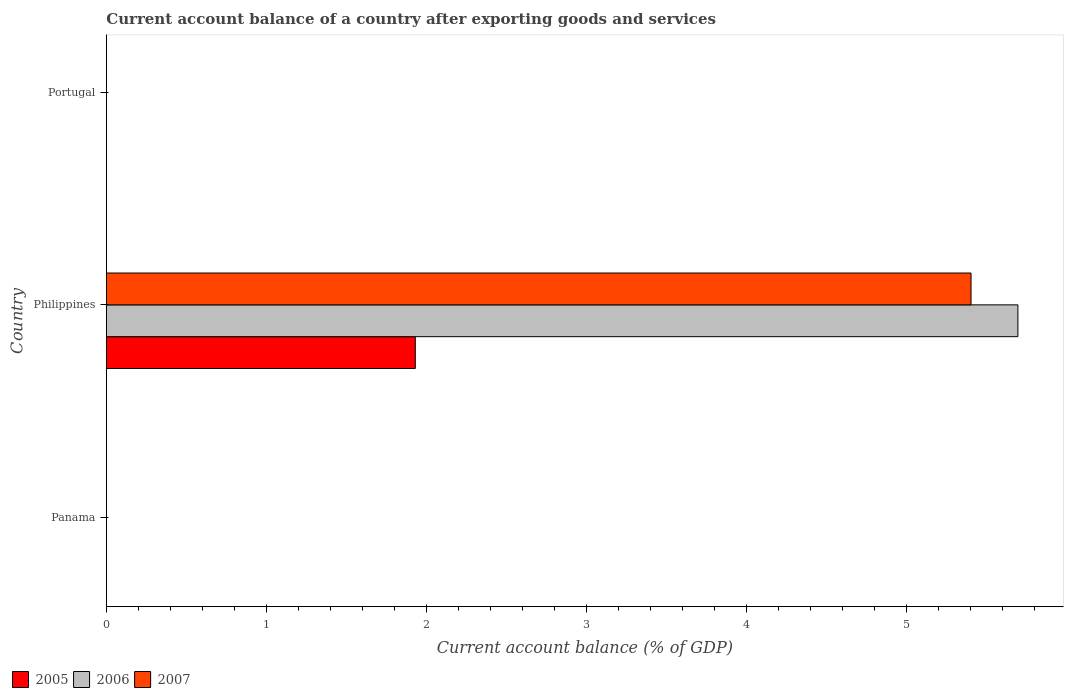Are the number of bars per tick equal to the number of legend labels?
Keep it short and to the point. No. How many bars are there on the 1st tick from the top?
Keep it short and to the point. 0. In how many cases, is the number of bars for a given country not equal to the number of legend labels?
Your answer should be very brief. 2. What is the account balance in 2007 in Portugal?
Provide a succinct answer. 0. Across all countries, what is the maximum account balance in 2005?
Offer a very short reply. 1.93. Across all countries, what is the minimum account balance in 2007?
Keep it short and to the point. 0. In which country was the account balance in 2007 maximum?
Provide a short and direct response. Philippines. What is the total account balance in 2005 in the graph?
Offer a very short reply. 1.93. What is the difference between the account balance in 2006 in Panama and the account balance in 2007 in Portugal?
Provide a short and direct response. 0. What is the average account balance in 2006 per country?
Keep it short and to the point. 1.9. What is the difference between the account balance in 2005 and account balance in 2007 in Philippines?
Make the answer very short. -3.47. In how many countries, is the account balance in 2005 greater than 4.6 %?
Keep it short and to the point. 0. What is the difference between the highest and the lowest account balance in 2006?
Your answer should be compact. 5.7. In how many countries, is the account balance in 2006 greater than the average account balance in 2006 taken over all countries?
Your answer should be compact. 1. Is it the case that in every country, the sum of the account balance in 2006 and account balance in 2005 is greater than the account balance in 2007?
Give a very brief answer. No. How many bars are there?
Give a very brief answer. 3. Are all the bars in the graph horizontal?
Keep it short and to the point. Yes. Are the values on the major ticks of X-axis written in scientific E-notation?
Your answer should be compact. No. Does the graph contain any zero values?
Provide a succinct answer. Yes. What is the title of the graph?
Your response must be concise. Current account balance of a country after exporting goods and services. Does "2012" appear as one of the legend labels in the graph?
Offer a very short reply. No. What is the label or title of the X-axis?
Provide a short and direct response. Current account balance (% of GDP). What is the label or title of the Y-axis?
Your response must be concise. Country. What is the Current account balance (% of GDP) of 2005 in Panama?
Offer a terse response. 0. What is the Current account balance (% of GDP) in 2006 in Panama?
Offer a terse response. 0. What is the Current account balance (% of GDP) of 2007 in Panama?
Your response must be concise. 0. What is the Current account balance (% of GDP) in 2005 in Philippines?
Keep it short and to the point. 1.93. What is the Current account balance (% of GDP) in 2006 in Philippines?
Offer a very short reply. 5.7. What is the Current account balance (% of GDP) of 2007 in Philippines?
Give a very brief answer. 5.4. What is the Current account balance (% of GDP) of 2006 in Portugal?
Your answer should be very brief. 0. Across all countries, what is the maximum Current account balance (% of GDP) of 2005?
Provide a short and direct response. 1.93. Across all countries, what is the maximum Current account balance (% of GDP) of 2006?
Keep it short and to the point. 5.7. Across all countries, what is the maximum Current account balance (% of GDP) in 2007?
Offer a terse response. 5.4. Across all countries, what is the minimum Current account balance (% of GDP) of 2006?
Offer a terse response. 0. Across all countries, what is the minimum Current account balance (% of GDP) in 2007?
Give a very brief answer. 0. What is the total Current account balance (% of GDP) of 2005 in the graph?
Your answer should be very brief. 1.93. What is the total Current account balance (% of GDP) of 2006 in the graph?
Give a very brief answer. 5.7. What is the total Current account balance (% of GDP) of 2007 in the graph?
Provide a short and direct response. 5.4. What is the average Current account balance (% of GDP) of 2005 per country?
Your response must be concise. 0.64. What is the average Current account balance (% of GDP) of 2006 per country?
Provide a short and direct response. 1.9. What is the average Current account balance (% of GDP) in 2007 per country?
Your response must be concise. 1.8. What is the difference between the Current account balance (% of GDP) of 2005 and Current account balance (% of GDP) of 2006 in Philippines?
Give a very brief answer. -3.77. What is the difference between the Current account balance (% of GDP) of 2005 and Current account balance (% of GDP) of 2007 in Philippines?
Keep it short and to the point. -3.47. What is the difference between the Current account balance (% of GDP) of 2006 and Current account balance (% of GDP) of 2007 in Philippines?
Your answer should be very brief. 0.29. What is the difference between the highest and the lowest Current account balance (% of GDP) in 2005?
Give a very brief answer. 1.93. What is the difference between the highest and the lowest Current account balance (% of GDP) of 2006?
Give a very brief answer. 5.7. What is the difference between the highest and the lowest Current account balance (% of GDP) of 2007?
Ensure brevity in your answer.  5.4. 